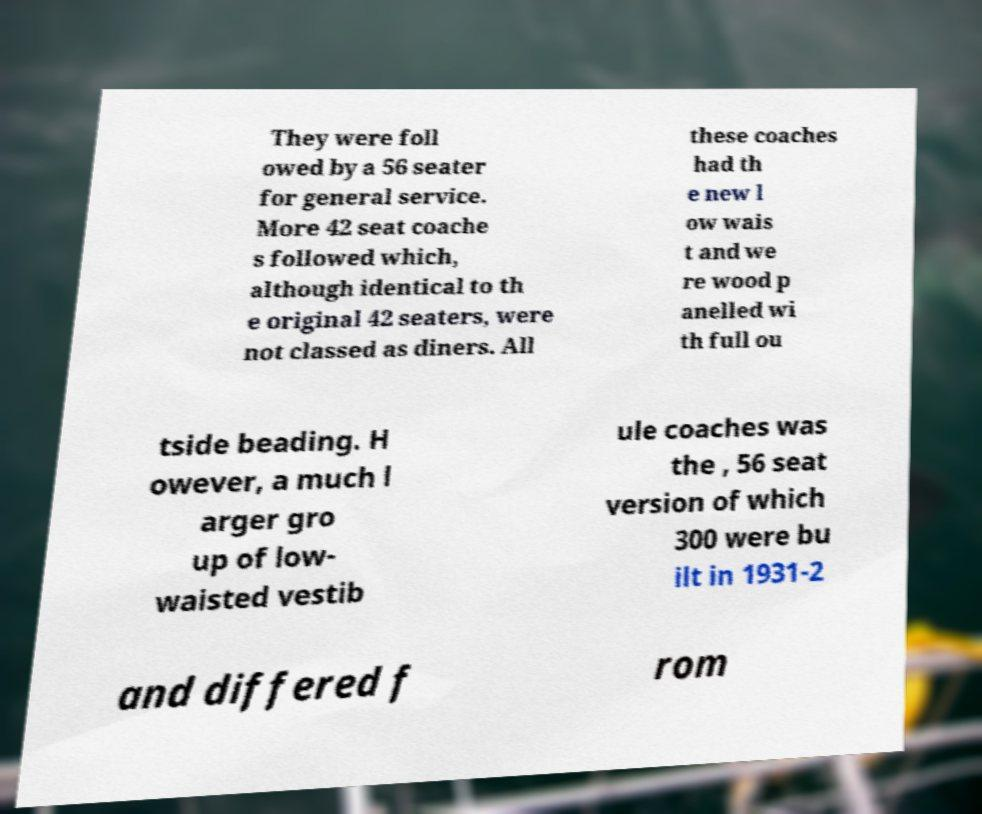Please identify and transcribe the text found in this image. They were foll owed by a 56 seater for general service. More 42 seat coache s followed which, although identical to th e original 42 seaters, were not classed as diners. All these coaches had th e new l ow wais t and we re wood p anelled wi th full ou tside beading. H owever, a much l arger gro up of low- waisted vestib ule coaches was the , 56 seat version of which 300 were bu ilt in 1931-2 and differed f rom 